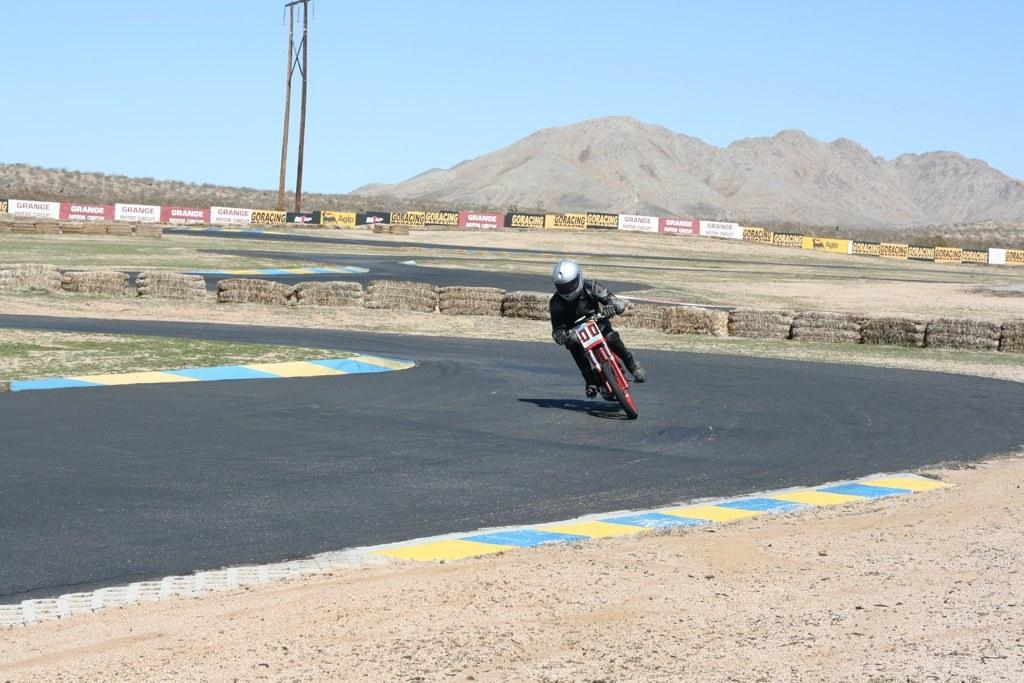What is the person in the image doing? There is a person riding a motor vehicle in the image. Where is the motor vehicle located? The motor vehicle is on the road. What type of landscape can be seen in the image? Hills are visible in the image. What else can be seen along the road in the image? Advertisement boards and poles are visible in the image. What is visible above the landscape and objects in the image? The sky is visible in the image. What type of throne is the person sitting on in the image? There is no throne present in the image; the person is riding a motor vehicle. What time of day is depicted in the image? The provided facts do not mention the time of day, so it cannot be determined from the image. 